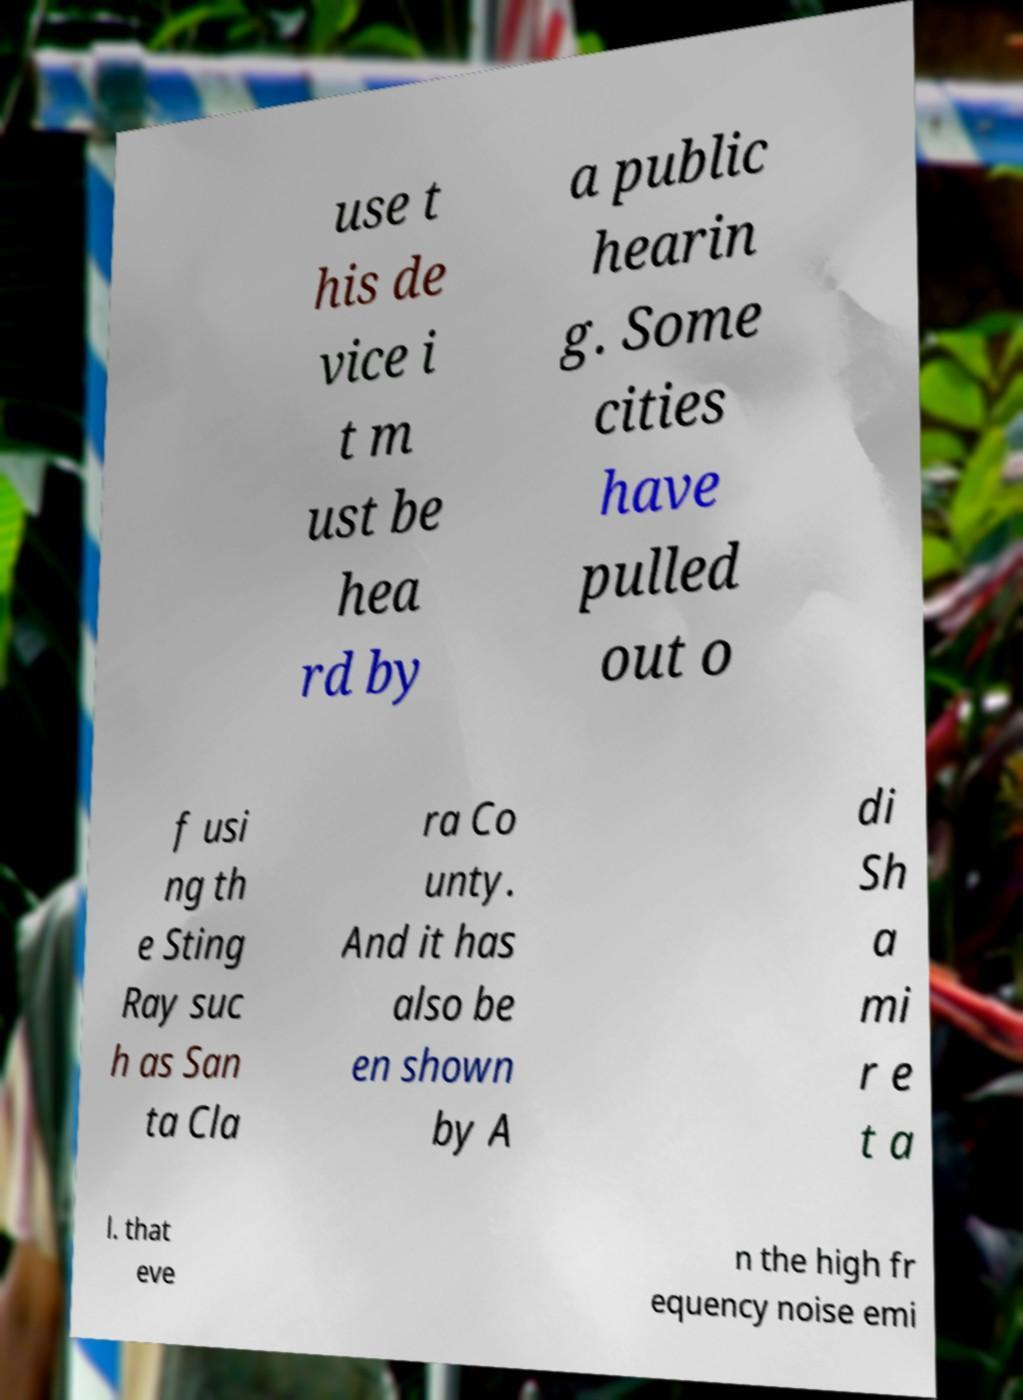There's text embedded in this image that I need extracted. Can you transcribe it verbatim? use t his de vice i t m ust be hea rd by a public hearin g. Some cities have pulled out o f usi ng th e Sting Ray suc h as San ta Cla ra Co unty. And it has also be en shown by A di Sh a mi r e t a l. that eve n the high fr equency noise emi 